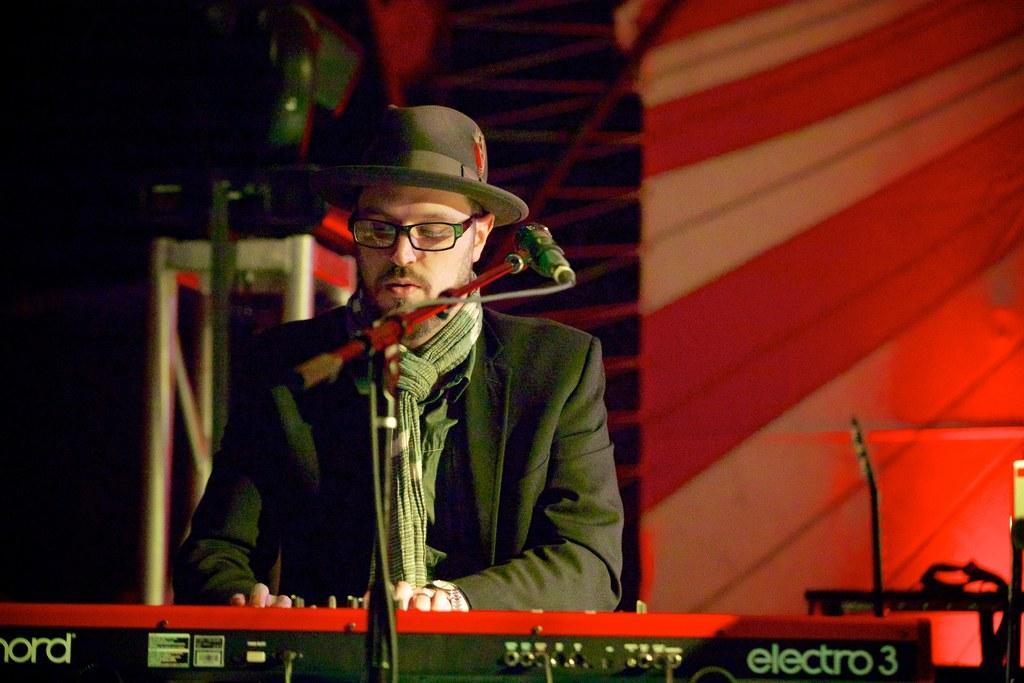In one or two sentences, can you explain what this image depicts? In the image there is man with suit and hat singing on mic and playing piano, this seems to be on stage, behind him there is cloth banner. he had scarf to his neck. 